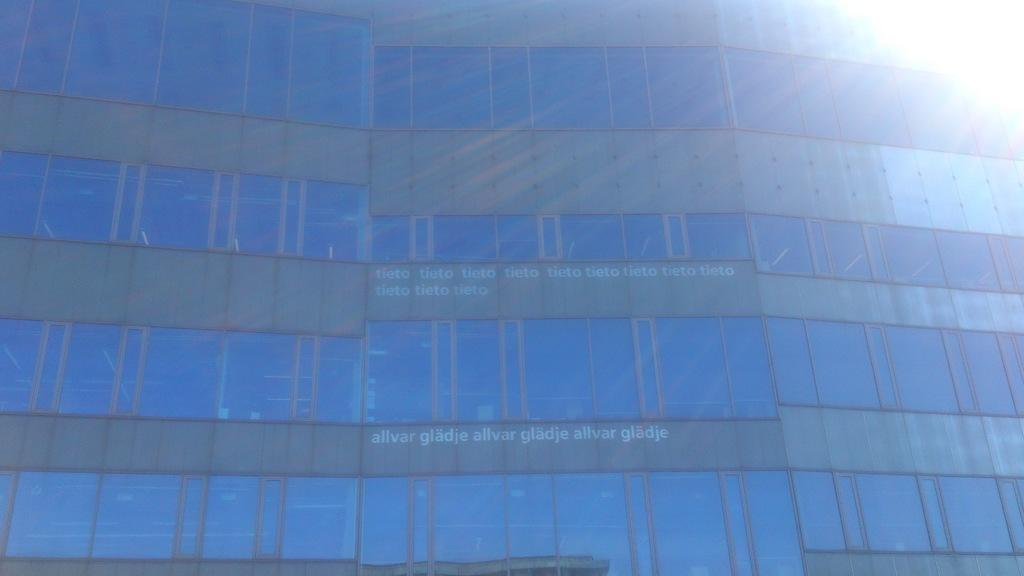What is the main structure in the image? There is a building in the image. What feature can be seen on the building? The building has windows. Is there any text or writing on the building? Yes, there is text or writing on the building. How does the building start to grow in the image? The building does not start to grow in the image; it is a static structure. 